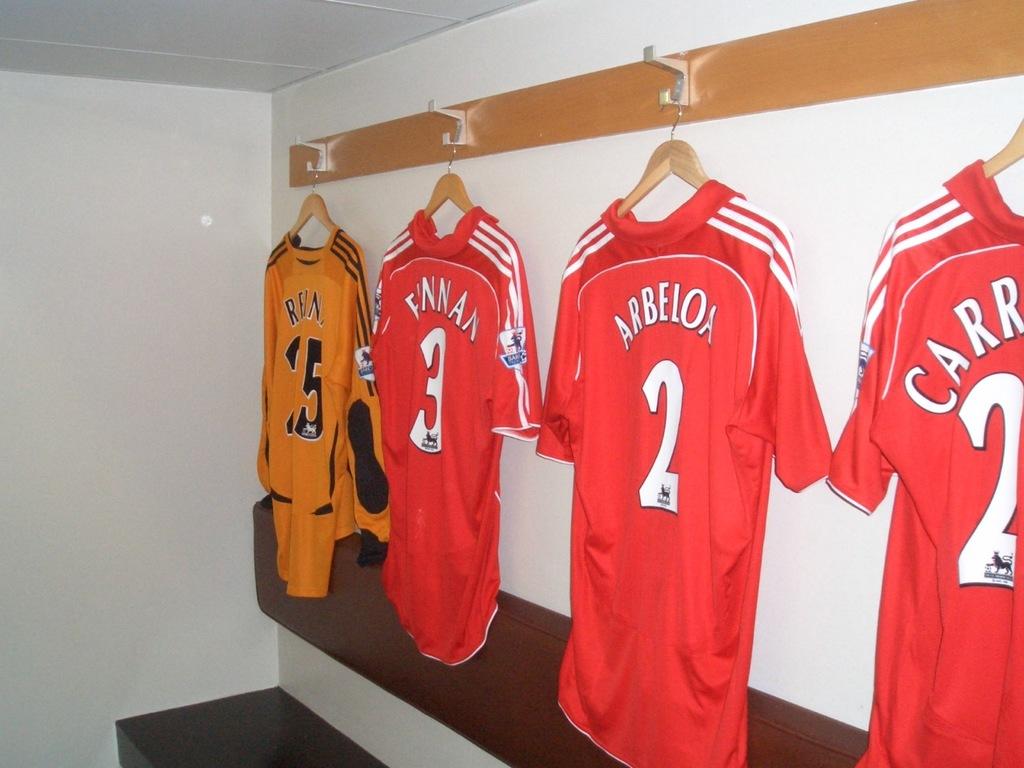What is the number on the left of the number two jersey?
Provide a short and direct response. 3. 